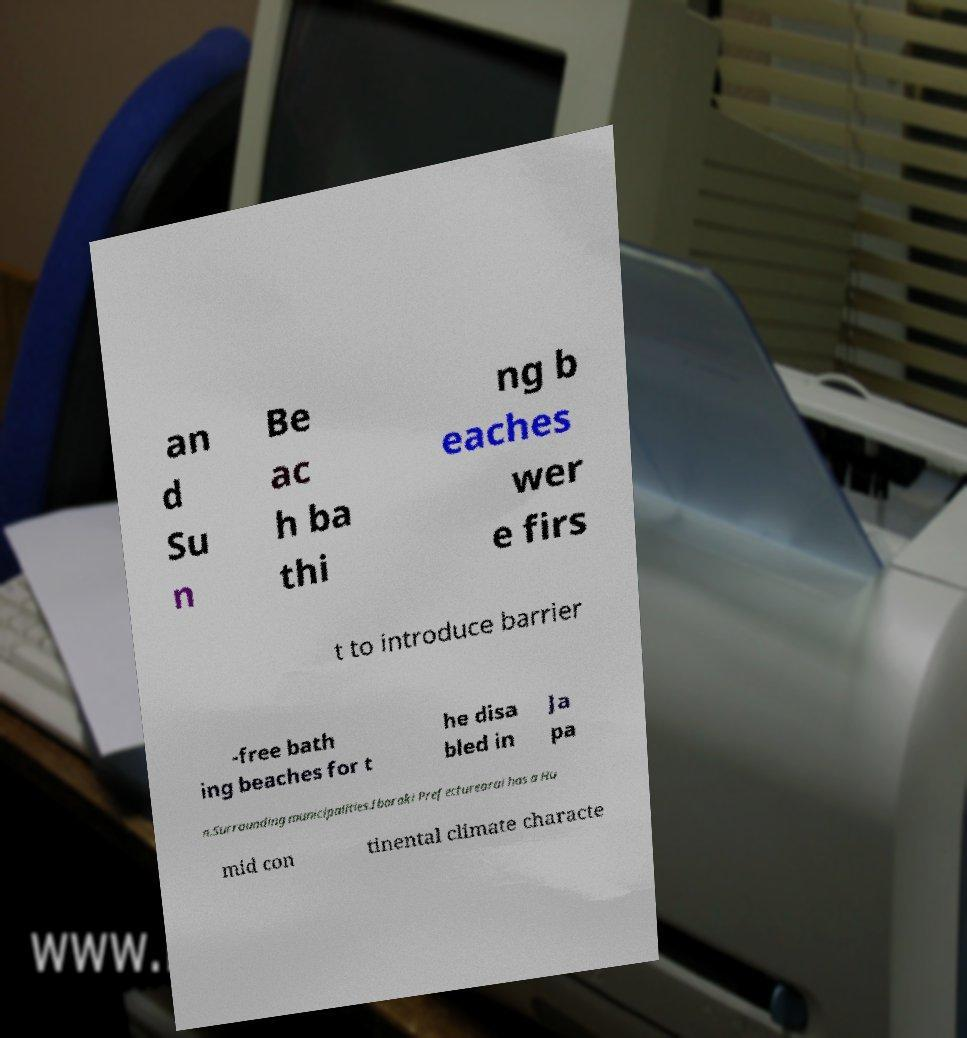Can you read and provide the text displayed in the image?This photo seems to have some interesting text. Can you extract and type it out for me? an d Su n Be ac h ba thi ng b eaches wer e firs t to introduce barrier -free bath ing beaches for t he disa bled in Ja pa n.Surrounding municipalities.Ibaraki Prefecturearai has a Hu mid con tinental climate characte 